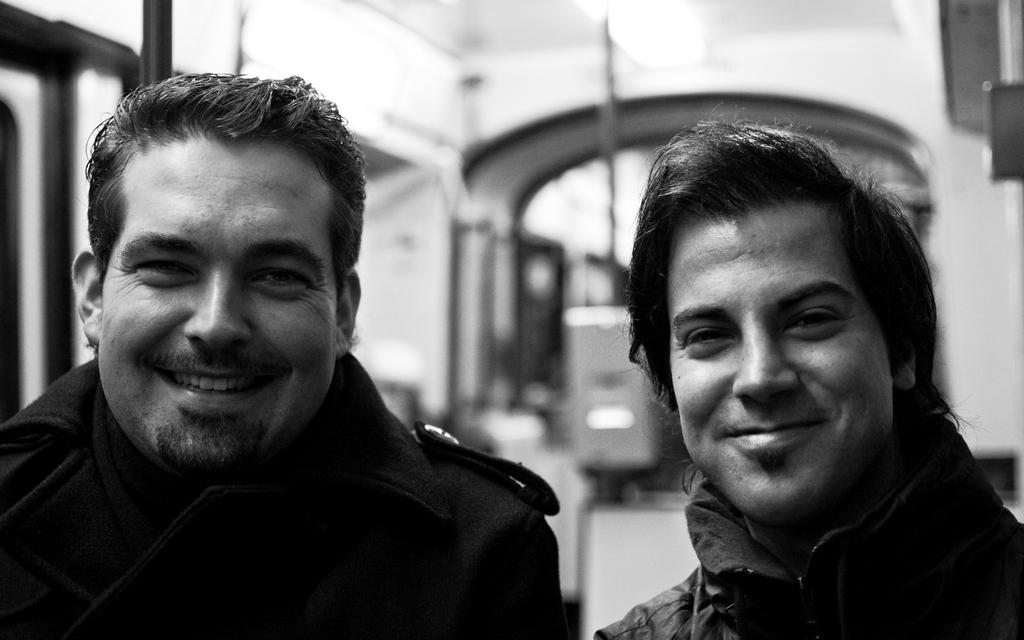How many people are in the image? There are two persons in the image. What can be seen in the image besides the people? There is a light and a pole in the image, as well as many objects visible behind the persons. What type of cart is being used to explain the theory in the image? There is no cart or theory present in the image; it features two persons, a light, and a pole. 